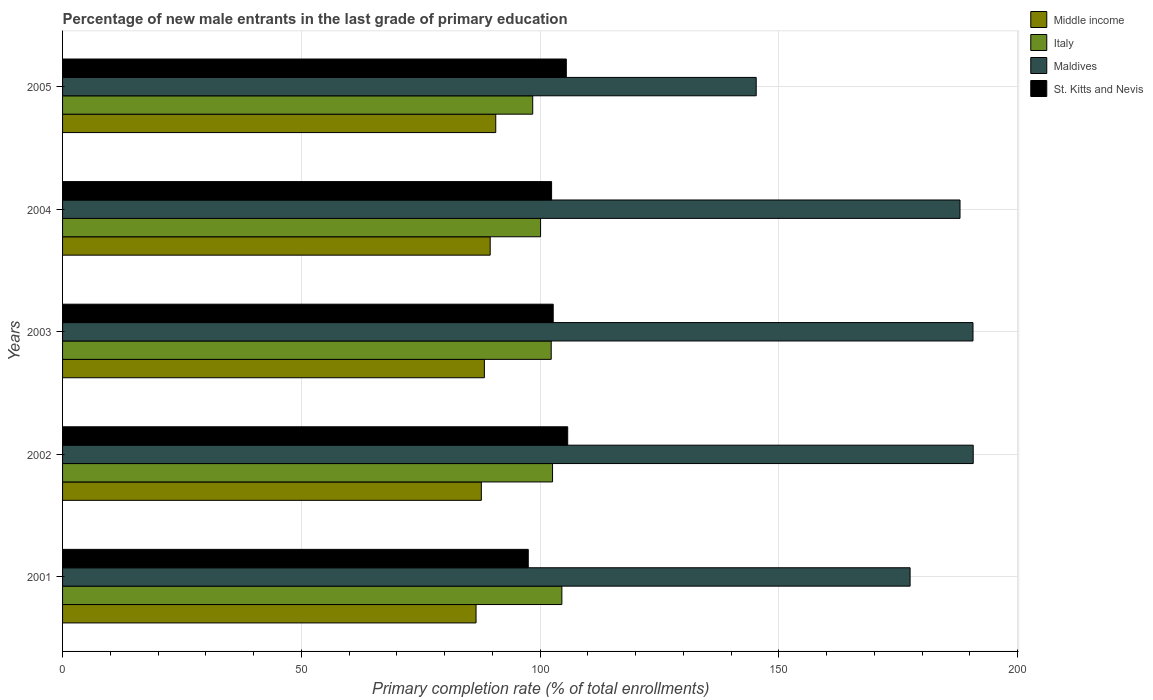How many different coloured bars are there?
Your answer should be very brief. 4. Are the number of bars per tick equal to the number of legend labels?
Make the answer very short. Yes. How many bars are there on the 1st tick from the top?
Provide a succinct answer. 4. What is the percentage of new male entrants in Italy in 2003?
Your response must be concise. 102.34. Across all years, what is the maximum percentage of new male entrants in Maldives?
Your response must be concise. 190.73. Across all years, what is the minimum percentage of new male entrants in Middle income?
Offer a very short reply. 86.6. In which year was the percentage of new male entrants in Italy maximum?
Your response must be concise. 2001. What is the total percentage of new male entrants in Maldives in the graph?
Offer a very short reply. 892.15. What is the difference between the percentage of new male entrants in Middle income in 2002 and that in 2005?
Keep it short and to the point. -3.02. What is the difference between the percentage of new male entrants in Maldives in 2004 and the percentage of new male entrants in Italy in 2002?
Provide a short and direct response. 85.34. What is the average percentage of new male entrants in Maldives per year?
Offer a terse response. 178.43. In the year 2004, what is the difference between the percentage of new male entrants in Middle income and percentage of new male entrants in Italy?
Make the answer very short. -10.55. What is the ratio of the percentage of new male entrants in Maldives in 2001 to that in 2002?
Keep it short and to the point. 0.93. Is the percentage of new male entrants in Maldives in 2001 less than that in 2005?
Your response must be concise. No. Is the difference between the percentage of new male entrants in Middle income in 2003 and 2004 greater than the difference between the percentage of new male entrants in Italy in 2003 and 2004?
Ensure brevity in your answer.  No. What is the difference between the highest and the second highest percentage of new male entrants in Middle income?
Make the answer very short. 1.17. What is the difference between the highest and the lowest percentage of new male entrants in Italy?
Give a very brief answer. 6.11. In how many years, is the percentage of new male entrants in Maldives greater than the average percentage of new male entrants in Maldives taken over all years?
Keep it short and to the point. 3. Is the sum of the percentage of new male entrants in Maldives in 2002 and 2003 greater than the maximum percentage of new male entrants in Italy across all years?
Make the answer very short. Yes. Is it the case that in every year, the sum of the percentage of new male entrants in St. Kitts and Nevis and percentage of new male entrants in Maldives is greater than the sum of percentage of new male entrants in Italy and percentage of new male entrants in Middle income?
Provide a succinct answer. Yes. What does the 2nd bar from the top in 2002 represents?
Provide a succinct answer. Maldives. What does the 2nd bar from the bottom in 2005 represents?
Give a very brief answer. Italy. How many bars are there?
Offer a terse response. 20. What is the difference between two consecutive major ticks on the X-axis?
Your response must be concise. 50. Does the graph contain any zero values?
Provide a short and direct response. No. Does the graph contain grids?
Your response must be concise. Yes. How many legend labels are there?
Ensure brevity in your answer.  4. What is the title of the graph?
Ensure brevity in your answer.  Percentage of new male entrants in the last grade of primary education. What is the label or title of the X-axis?
Provide a short and direct response. Primary completion rate (% of total enrollments). What is the label or title of the Y-axis?
Give a very brief answer. Years. What is the Primary completion rate (% of total enrollments) of Middle income in 2001?
Provide a short and direct response. 86.6. What is the Primary completion rate (% of total enrollments) in Italy in 2001?
Offer a very short reply. 104.57. What is the Primary completion rate (% of total enrollments) of Maldives in 2001?
Give a very brief answer. 177.51. What is the Primary completion rate (% of total enrollments) in St. Kitts and Nevis in 2001?
Your answer should be very brief. 97.54. What is the Primary completion rate (% of total enrollments) of Middle income in 2002?
Keep it short and to the point. 87.71. What is the Primary completion rate (% of total enrollments) in Italy in 2002?
Your response must be concise. 102.62. What is the Primary completion rate (% of total enrollments) of Maldives in 2002?
Ensure brevity in your answer.  190.73. What is the Primary completion rate (% of total enrollments) in St. Kitts and Nevis in 2002?
Keep it short and to the point. 105.8. What is the Primary completion rate (% of total enrollments) of Middle income in 2003?
Make the answer very short. 88.34. What is the Primary completion rate (% of total enrollments) of Italy in 2003?
Keep it short and to the point. 102.34. What is the Primary completion rate (% of total enrollments) in Maldives in 2003?
Offer a very short reply. 190.68. What is the Primary completion rate (% of total enrollments) of St. Kitts and Nevis in 2003?
Provide a succinct answer. 102.76. What is the Primary completion rate (% of total enrollments) of Middle income in 2004?
Make the answer very short. 89.56. What is the Primary completion rate (% of total enrollments) in Italy in 2004?
Keep it short and to the point. 100.11. What is the Primary completion rate (% of total enrollments) in Maldives in 2004?
Make the answer very short. 187.96. What is the Primary completion rate (% of total enrollments) of St. Kitts and Nevis in 2004?
Offer a very short reply. 102.42. What is the Primary completion rate (% of total enrollments) in Middle income in 2005?
Your response must be concise. 90.73. What is the Primary completion rate (% of total enrollments) in Italy in 2005?
Provide a succinct answer. 98.47. What is the Primary completion rate (% of total enrollments) in Maldives in 2005?
Give a very brief answer. 145.27. What is the Primary completion rate (% of total enrollments) in St. Kitts and Nevis in 2005?
Your response must be concise. 105.5. Across all years, what is the maximum Primary completion rate (% of total enrollments) of Middle income?
Provide a short and direct response. 90.73. Across all years, what is the maximum Primary completion rate (% of total enrollments) of Italy?
Your answer should be compact. 104.57. Across all years, what is the maximum Primary completion rate (% of total enrollments) of Maldives?
Give a very brief answer. 190.73. Across all years, what is the maximum Primary completion rate (% of total enrollments) in St. Kitts and Nevis?
Keep it short and to the point. 105.8. Across all years, what is the minimum Primary completion rate (% of total enrollments) in Middle income?
Offer a terse response. 86.6. Across all years, what is the minimum Primary completion rate (% of total enrollments) in Italy?
Your response must be concise. 98.47. Across all years, what is the minimum Primary completion rate (% of total enrollments) in Maldives?
Offer a very short reply. 145.27. Across all years, what is the minimum Primary completion rate (% of total enrollments) in St. Kitts and Nevis?
Keep it short and to the point. 97.54. What is the total Primary completion rate (% of total enrollments) of Middle income in the graph?
Give a very brief answer. 442.94. What is the total Primary completion rate (% of total enrollments) of Italy in the graph?
Offer a terse response. 508.12. What is the total Primary completion rate (% of total enrollments) in Maldives in the graph?
Offer a very short reply. 892.15. What is the total Primary completion rate (% of total enrollments) in St. Kitts and Nevis in the graph?
Your answer should be very brief. 514.02. What is the difference between the Primary completion rate (% of total enrollments) in Middle income in 2001 and that in 2002?
Your answer should be very brief. -1.11. What is the difference between the Primary completion rate (% of total enrollments) of Italy in 2001 and that in 2002?
Your answer should be very brief. 1.95. What is the difference between the Primary completion rate (% of total enrollments) in Maldives in 2001 and that in 2002?
Your answer should be very brief. -13.22. What is the difference between the Primary completion rate (% of total enrollments) in St. Kitts and Nevis in 2001 and that in 2002?
Your response must be concise. -8.26. What is the difference between the Primary completion rate (% of total enrollments) in Middle income in 2001 and that in 2003?
Keep it short and to the point. -1.74. What is the difference between the Primary completion rate (% of total enrollments) of Italy in 2001 and that in 2003?
Your answer should be very brief. 2.23. What is the difference between the Primary completion rate (% of total enrollments) in Maldives in 2001 and that in 2003?
Provide a succinct answer. -13.17. What is the difference between the Primary completion rate (% of total enrollments) in St. Kitts and Nevis in 2001 and that in 2003?
Your response must be concise. -5.22. What is the difference between the Primary completion rate (% of total enrollments) in Middle income in 2001 and that in 2004?
Offer a very short reply. -2.96. What is the difference between the Primary completion rate (% of total enrollments) of Italy in 2001 and that in 2004?
Ensure brevity in your answer.  4.46. What is the difference between the Primary completion rate (% of total enrollments) in Maldives in 2001 and that in 2004?
Your response must be concise. -10.46. What is the difference between the Primary completion rate (% of total enrollments) in St. Kitts and Nevis in 2001 and that in 2004?
Provide a succinct answer. -4.89. What is the difference between the Primary completion rate (% of total enrollments) in Middle income in 2001 and that in 2005?
Offer a very short reply. -4.13. What is the difference between the Primary completion rate (% of total enrollments) in Italy in 2001 and that in 2005?
Ensure brevity in your answer.  6.11. What is the difference between the Primary completion rate (% of total enrollments) in Maldives in 2001 and that in 2005?
Provide a short and direct response. 32.23. What is the difference between the Primary completion rate (% of total enrollments) in St. Kitts and Nevis in 2001 and that in 2005?
Provide a succinct answer. -7.97. What is the difference between the Primary completion rate (% of total enrollments) of Middle income in 2002 and that in 2003?
Offer a very short reply. -0.64. What is the difference between the Primary completion rate (% of total enrollments) in Italy in 2002 and that in 2003?
Offer a very short reply. 0.28. What is the difference between the Primary completion rate (% of total enrollments) of Maldives in 2002 and that in 2003?
Make the answer very short. 0.05. What is the difference between the Primary completion rate (% of total enrollments) of St. Kitts and Nevis in 2002 and that in 2003?
Ensure brevity in your answer.  3.04. What is the difference between the Primary completion rate (% of total enrollments) of Middle income in 2002 and that in 2004?
Provide a succinct answer. -1.85. What is the difference between the Primary completion rate (% of total enrollments) of Italy in 2002 and that in 2004?
Your response must be concise. 2.51. What is the difference between the Primary completion rate (% of total enrollments) in Maldives in 2002 and that in 2004?
Provide a short and direct response. 2.77. What is the difference between the Primary completion rate (% of total enrollments) of St. Kitts and Nevis in 2002 and that in 2004?
Ensure brevity in your answer.  3.37. What is the difference between the Primary completion rate (% of total enrollments) of Middle income in 2002 and that in 2005?
Offer a very short reply. -3.02. What is the difference between the Primary completion rate (% of total enrollments) of Italy in 2002 and that in 2005?
Keep it short and to the point. 4.15. What is the difference between the Primary completion rate (% of total enrollments) of Maldives in 2002 and that in 2005?
Keep it short and to the point. 45.45. What is the difference between the Primary completion rate (% of total enrollments) in St. Kitts and Nevis in 2002 and that in 2005?
Offer a terse response. 0.29. What is the difference between the Primary completion rate (% of total enrollments) of Middle income in 2003 and that in 2004?
Give a very brief answer. -1.22. What is the difference between the Primary completion rate (% of total enrollments) in Italy in 2003 and that in 2004?
Keep it short and to the point. 2.23. What is the difference between the Primary completion rate (% of total enrollments) of Maldives in 2003 and that in 2004?
Provide a short and direct response. 2.72. What is the difference between the Primary completion rate (% of total enrollments) of St. Kitts and Nevis in 2003 and that in 2004?
Keep it short and to the point. 0.34. What is the difference between the Primary completion rate (% of total enrollments) of Middle income in 2003 and that in 2005?
Your response must be concise. -2.38. What is the difference between the Primary completion rate (% of total enrollments) of Italy in 2003 and that in 2005?
Make the answer very short. 3.87. What is the difference between the Primary completion rate (% of total enrollments) of Maldives in 2003 and that in 2005?
Your answer should be very brief. 45.41. What is the difference between the Primary completion rate (% of total enrollments) of St. Kitts and Nevis in 2003 and that in 2005?
Ensure brevity in your answer.  -2.74. What is the difference between the Primary completion rate (% of total enrollments) of Middle income in 2004 and that in 2005?
Keep it short and to the point. -1.17. What is the difference between the Primary completion rate (% of total enrollments) in Italy in 2004 and that in 2005?
Your response must be concise. 1.64. What is the difference between the Primary completion rate (% of total enrollments) of Maldives in 2004 and that in 2005?
Provide a succinct answer. 42.69. What is the difference between the Primary completion rate (% of total enrollments) in St. Kitts and Nevis in 2004 and that in 2005?
Make the answer very short. -3.08. What is the difference between the Primary completion rate (% of total enrollments) in Middle income in 2001 and the Primary completion rate (% of total enrollments) in Italy in 2002?
Provide a short and direct response. -16.02. What is the difference between the Primary completion rate (% of total enrollments) of Middle income in 2001 and the Primary completion rate (% of total enrollments) of Maldives in 2002?
Your response must be concise. -104.13. What is the difference between the Primary completion rate (% of total enrollments) of Middle income in 2001 and the Primary completion rate (% of total enrollments) of St. Kitts and Nevis in 2002?
Offer a terse response. -19.2. What is the difference between the Primary completion rate (% of total enrollments) of Italy in 2001 and the Primary completion rate (% of total enrollments) of Maldives in 2002?
Offer a very short reply. -86.15. What is the difference between the Primary completion rate (% of total enrollments) in Italy in 2001 and the Primary completion rate (% of total enrollments) in St. Kitts and Nevis in 2002?
Your answer should be very brief. -1.22. What is the difference between the Primary completion rate (% of total enrollments) in Maldives in 2001 and the Primary completion rate (% of total enrollments) in St. Kitts and Nevis in 2002?
Provide a short and direct response. 71.71. What is the difference between the Primary completion rate (% of total enrollments) of Middle income in 2001 and the Primary completion rate (% of total enrollments) of Italy in 2003?
Give a very brief answer. -15.75. What is the difference between the Primary completion rate (% of total enrollments) of Middle income in 2001 and the Primary completion rate (% of total enrollments) of Maldives in 2003?
Offer a very short reply. -104.08. What is the difference between the Primary completion rate (% of total enrollments) of Middle income in 2001 and the Primary completion rate (% of total enrollments) of St. Kitts and Nevis in 2003?
Provide a succinct answer. -16.16. What is the difference between the Primary completion rate (% of total enrollments) in Italy in 2001 and the Primary completion rate (% of total enrollments) in Maldives in 2003?
Give a very brief answer. -86.11. What is the difference between the Primary completion rate (% of total enrollments) of Italy in 2001 and the Primary completion rate (% of total enrollments) of St. Kitts and Nevis in 2003?
Your response must be concise. 1.81. What is the difference between the Primary completion rate (% of total enrollments) of Maldives in 2001 and the Primary completion rate (% of total enrollments) of St. Kitts and Nevis in 2003?
Provide a succinct answer. 74.75. What is the difference between the Primary completion rate (% of total enrollments) in Middle income in 2001 and the Primary completion rate (% of total enrollments) in Italy in 2004?
Make the answer very short. -13.52. What is the difference between the Primary completion rate (% of total enrollments) of Middle income in 2001 and the Primary completion rate (% of total enrollments) of Maldives in 2004?
Your answer should be compact. -101.36. What is the difference between the Primary completion rate (% of total enrollments) of Middle income in 2001 and the Primary completion rate (% of total enrollments) of St. Kitts and Nevis in 2004?
Ensure brevity in your answer.  -15.83. What is the difference between the Primary completion rate (% of total enrollments) in Italy in 2001 and the Primary completion rate (% of total enrollments) in Maldives in 2004?
Offer a very short reply. -83.39. What is the difference between the Primary completion rate (% of total enrollments) in Italy in 2001 and the Primary completion rate (% of total enrollments) in St. Kitts and Nevis in 2004?
Your answer should be very brief. 2.15. What is the difference between the Primary completion rate (% of total enrollments) of Maldives in 2001 and the Primary completion rate (% of total enrollments) of St. Kitts and Nevis in 2004?
Your response must be concise. 75.08. What is the difference between the Primary completion rate (% of total enrollments) of Middle income in 2001 and the Primary completion rate (% of total enrollments) of Italy in 2005?
Offer a very short reply. -11.87. What is the difference between the Primary completion rate (% of total enrollments) in Middle income in 2001 and the Primary completion rate (% of total enrollments) in Maldives in 2005?
Ensure brevity in your answer.  -58.68. What is the difference between the Primary completion rate (% of total enrollments) in Middle income in 2001 and the Primary completion rate (% of total enrollments) in St. Kitts and Nevis in 2005?
Offer a terse response. -18.91. What is the difference between the Primary completion rate (% of total enrollments) of Italy in 2001 and the Primary completion rate (% of total enrollments) of Maldives in 2005?
Your response must be concise. -40.7. What is the difference between the Primary completion rate (% of total enrollments) of Italy in 2001 and the Primary completion rate (% of total enrollments) of St. Kitts and Nevis in 2005?
Ensure brevity in your answer.  -0.93. What is the difference between the Primary completion rate (% of total enrollments) of Maldives in 2001 and the Primary completion rate (% of total enrollments) of St. Kitts and Nevis in 2005?
Keep it short and to the point. 72. What is the difference between the Primary completion rate (% of total enrollments) of Middle income in 2002 and the Primary completion rate (% of total enrollments) of Italy in 2003?
Offer a terse response. -14.64. What is the difference between the Primary completion rate (% of total enrollments) in Middle income in 2002 and the Primary completion rate (% of total enrollments) in Maldives in 2003?
Your answer should be compact. -102.97. What is the difference between the Primary completion rate (% of total enrollments) in Middle income in 2002 and the Primary completion rate (% of total enrollments) in St. Kitts and Nevis in 2003?
Keep it short and to the point. -15.05. What is the difference between the Primary completion rate (% of total enrollments) in Italy in 2002 and the Primary completion rate (% of total enrollments) in Maldives in 2003?
Provide a succinct answer. -88.06. What is the difference between the Primary completion rate (% of total enrollments) of Italy in 2002 and the Primary completion rate (% of total enrollments) of St. Kitts and Nevis in 2003?
Offer a terse response. -0.14. What is the difference between the Primary completion rate (% of total enrollments) in Maldives in 2002 and the Primary completion rate (% of total enrollments) in St. Kitts and Nevis in 2003?
Offer a terse response. 87.97. What is the difference between the Primary completion rate (% of total enrollments) of Middle income in 2002 and the Primary completion rate (% of total enrollments) of Italy in 2004?
Provide a succinct answer. -12.41. What is the difference between the Primary completion rate (% of total enrollments) of Middle income in 2002 and the Primary completion rate (% of total enrollments) of Maldives in 2004?
Your response must be concise. -100.26. What is the difference between the Primary completion rate (% of total enrollments) of Middle income in 2002 and the Primary completion rate (% of total enrollments) of St. Kitts and Nevis in 2004?
Your answer should be compact. -14.72. What is the difference between the Primary completion rate (% of total enrollments) in Italy in 2002 and the Primary completion rate (% of total enrollments) in Maldives in 2004?
Offer a terse response. -85.34. What is the difference between the Primary completion rate (% of total enrollments) of Italy in 2002 and the Primary completion rate (% of total enrollments) of St. Kitts and Nevis in 2004?
Offer a terse response. 0.2. What is the difference between the Primary completion rate (% of total enrollments) in Maldives in 2002 and the Primary completion rate (% of total enrollments) in St. Kitts and Nevis in 2004?
Your answer should be compact. 88.3. What is the difference between the Primary completion rate (% of total enrollments) in Middle income in 2002 and the Primary completion rate (% of total enrollments) in Italy in 2005?
Provide a succinct answer. -10.76. What is the difference between the Primary completion rate (% of total enrollments) of Middle income in 2002 and the Primary completion rate (% of total enrollments) of Maldives in 2005?
Your response must be concise. -57.57. What is the difference between the Primary completion rate (% of total enrollments) in Middle income in 2002 and the Primary completion rate (% of total enrollments) in St. Kitts and Nevis in 2005?
Provide a short and direct response. -17.8. What is the difference between the Primary completion rate (% of total enrollments) in Italy in 2002 and the Primary completion rate (% of total enrollments) in Maldives in 2005?
Offer a very short reply. -42.65. What is the difference between the Primary completion rate (% of total enrollments) of Italy in 2002 and the Primary completion rate (% of total enrollments) of St. Kitts and Nevis in 2005?
Make the answer very short. -2.88. What is the difference between the Primary completion rate (% of total enrollments) of Maldives in 2002 and the Primary completion rate (% of total enrollments) of St. Kitts and Nevis in 2005?
Ensure brevity in your answer.  85.22. What is the difference between the Primary completion rate (% of total enrollments) in Middle income in 2003 and the Primary completion rate (% of total enrollments) in Italy in 2004?
Offer a terse response. -11.77. What is the difference between the Primary completion rate (% of total enrollments) of Middle income in 2003 and the Primary completion rate (% of total enrollments) of Maldives in 2004?
Offer a terse response. -99.62. What is the difference between the Primary completion rate (% of total enrollments) in Middle income in 2003 and the Primary completion rate (% of total enrollments) in St. Kitts and Nevis in 2004?
Your answer should be compact. -14.08. What is the difference between the Primary completion rate (% of total enrollments) in Italy in 2003 and the Primary completion rate (% of total enrollments) in Maldives in 2004?
Provide a short and direct response. -85.62. What is the difference between the Primary completion rate (% of total enrollments) in Italy in 2003 and the Primary completion rate (% of total enrollments) in St. Kitts and Nevis in 2004?
Your response must be concise. -0.08. What is the difference between the Primary completion rate (% of total enrollments) in Maldives in 2003 and the Primary completion rate (% of total enrollments) in St. Kitts and Nevis in 2004?
Provide a succinct answer. 88.26. What is the difference between the Primary completion rate (% of total enrollments) of Middle income in 2003 and the Primary completion rate (% of total enrollments) of Italy in 2005?
Ensure brevity in your answer.  -10.13. What is the difference between the Primary completion rate (% of total enrollments) of Middle income in 2003 and the Primary completion rate (% of total enrollments) of Maldives in 2005?
Give a very brief answer. -56.93. What is the difference between the Primary completion rate (% of total enrollments) of Middle income in 2003 and the Primary completion rate (% of total enrollments) of St. Kitts and Nevis in 2005?
Keep it short and to the point. -17.16. What is the difference between the Primary completion rate (% of total enrollments) in Italy in 2003 and the Primary completion rate (% of total enrollments) in Maldives in 2005?
Your answer should be very brief. -42.93. What is the difference between the Primary completion rate (% of total enrollments) of Italy in 2003 and the Primary completion rate (% of total enrollments) of St. Kitts and Nevis in 2005?
Provide a short and direct response. -3.16. What is the difference between the Primary completion rate (% of total enrollments) in Maldives in 2003 and the Primary completion rate (% of total enrollments) in St. Kitts and Nevis in 2005?
Give a very brief answer. 85.18. What is the difference between the Primary completion rate (% of total enrollments) of Middle income in 2004 and the Primary completion rate (% of total enrollments) of Italy in 2005?
Offer a very short reply. -8.91. What is the difference between the Primary completion rate (% of total enrollments) of Middle income in 2004 and the Primary completion rate (% of total enrollments) of Maldives in 2005?
Offer a very short reply. -55.71. What is the difference between the Primary completion rate (% of total enrollments) in Middle income in 2004 and the Primary completion rate (% of total enrollments) in St. Kitts and Nevis in 2005?
Your answer should be compact. -15.94. What is the difference between the Primary completion rate (% of total enrollments) of Italy in 2004 and the Primary completion rate (% of total enrollments) of Maldives in 2005?
Your answer should be compact. -45.16. What is the difference between the Primary completion rate (% of total enrollments) in Italy in 2004 and the Primary completion rate (% of total enrollments) in St. Kitts and Nevis in 2005?
Offer a terse response. -5.39. What is the difference between the Primary completion rate (% of total enrollments) in Maldives in 2004 and the Primary completion rate (% of total enrollments) in St. Kitts and Nevis in 2005?
Provide a short and direct response. 82.46. What is the average Primary completion rate (% of total enrollments) in Middle income per year?
Your response must be concise. 88.59. What is the average Primary completion rate (% of total enrollments) of Italy per year?
Offer a very short reply. 101.62. What is the average Primary completion rate (% of total enrollments) in Maldives per year?
Offer a very short reply. 178.43. What is the average Primary completion rate (% of total enrollments) in St. Kitts and Nevis per year?
Your answer should be compact. 102.8. In the year 2001, what is the difference between the Primary completion rate (% of total enrollments) of Middle income and Primary completion rate (% of total enrollments) of Italy?
Provide a succinct answer. -17.98. In the year 2001, what is the difference between the Primary completion rate (% of total enrollments) of Middle income and Primary completion rate (% of total enrollments) of Maldives?
Make the answer very short. -90.91. In the year 2001, what is the difference between the Primary completion rate (% of total enrollments) of Middle income and Primary completion rate (% of total enrollments) of St. Kitts and Nevis?
Make the answer very short. -10.94. In the year 2001, what is the difference between the Primary completion rate (% of total enrollments) in Italy and Primary completion rate (% of total enrollments) in Maldives?
Your answer should be compact. -72.93. In the year 2001, what is the difference between the Primary completion rate (% of total enrollments) of Italy and Primary completion rate (% of total enrollments) of St. Kitts and Nevis?
Provide a succinct answer. 7.04. In the year 2001, what is the difference between the Primary completion rate (% of total enrollments) of Maldives and Primary completion rate (% of total enrollments) of St. Kitts and Nevis?
Offer a terse response. 79.97. In the year 2002, what is the difference between the Primary completion rate (% of total enrollments) in Middle income and Primary completion rate (% of total enrollments) in Italy?
Your response must be concise. -14.91. In the year 2002, what is the difference between the Primary completion rate (% of total enrollments) of Middle income and Primary completion rate (% of total enrollments) of Maldives?
Ensure brevity in your answer.  -103.02. In the year 2002, what is the difference between the Primary completion rate (% of total enrollments) of Middle income and Primary completion rate (% of total enrollments) of St. Kitts and Nevis?
Provide a succinct answer. -18.09. In the year 2002, what is the difference between the Primary completion rate (% of total enrollments) in Italy and Primary completion rate (% of total enrollments) in Maldives?
Provide a succinct answer. -88.11. In the year 2002, what is the difference between the Primary completion rate (% of total enrollments) of Italy and Primary completion rate (% of total enrollments) of St. Kitts and Nevis?
Your answer should be compact. -3.18. In the year 2002, what is the difference between the Primary completion rate (% of total enrollments) in Maldives and Primary completion rate (% of total enrollments) in St. Kitts and Nevis?
Offer a terse response. 84.93. In the year 2003, what is the difference between the Primary completion rate (% of total enrollments) in Middle income and Primary completion rate (% of total enrollments) in Italy?
Your response must be concise. -14. In the year 2003, what is the difference between the Primary completion rate (% of total enrollments) of Middle income and Primary completion rate (% of total enrollments) of Maldives?
Provide a short and direct response. -102.34. In the year 2003, what is the difference between the Primary completion rate (% of total enrollments) of Middle income and Primary completion rate (% of total enrollments) of St. Kitts and Nevis?
Provide a short and direct response. -14.42. In the year 2003, what is the difference between the Primary completion rate (% of total enrollments) of Italy and Primary completion rate (% of total enrollments) of Maldives?
Give a very brief answer. -88.34. In the year 2003, what is the difference between the Primary completion rate (% of total enrollments) of Italy and Primary completion rate (% of total enrollments) of St. Kitts and Nevis?
Offer a terse response. -0.42. In the year 2003, what is the difference between the Primary completion rate (% of total enrollments) in Maldives and Primary completion rate (% of total enrollments) in St. Kitts and Nevis?
Your answer should be very brief. 87.92. In the year 2004, what is the difference between the Primary completion rate (% of total enrollments) of Middle income and Primary completion rate (% of total enrollments) of Italy?
Make the answer very short. -10.55. In the year 2004, what is the difference between the Primary completion rate (% of total enrollments) of Middle income and Primary completion rate (% of total enrollments) of Maldives?
Keep it short and to the point. -98.4. In the year 2004, what is the difference between the Primary completion rate (% of total enrollments) in Middle income and Primary completion rate (% of total enrollments) in St. Kitts and Nevis?
Offer a very short reply. -12.86. In the year 2004, what is the difference between the Primary completion rate (% of total enrollments) in Italy and Primary completion rate (% of total enrollments) in Maldives?
Your response must be concise. -87.85. In the year 2004, what is the difference between the Primary completion rate (% of total enrollments) of Italy and Primary completion rate (% of total enrollments) of St. Kitts and Nevis?
Keep it short and to the point. -2.31. In the year 2004, what is the difference between the Primary completion rate (% of total enrollments) in Maldives and Primary completion rate (% of total enrollments) in St. Kitts and Nevis?
Your answer should be very brief. 85.54. In the year 2005, what is the difference between the Primary completion rate (% of total enrollments) of Middle income and Primary completion rate (% of total enrollments) of Italy?
Offer a terse response. -7.74. In the year 2005, what is the difference between the Primary completion rate (% of total enrollments) of Middle income and Primary completion rate (% of total enrollments) of Maldives?
Your response must be concise. -54.55. In the year 2005, what is the difference between the Primary completion rate (% of total enrollments) of Middle income and Primary completion rate (% of total enrollments) of St. Kitts and Nevis?
Keep it short and to the point. -14.78. In the year 2005, what is the difference between the Primary completion rate (% of total enrollments) of Italy and Primary completion rate (% of total enrollments) of Maldives?
Provide a succinct answer. -46.81. In the year 2005, what is the difference between the Primary completion rate (% of total enrollments) in Italy and Primary completion rate (% of total enrollments) in St. Kitts and Nevis?
Ensure brevity in your answer.  -7.04. In the year 2005, what is the difference between the Primary completion rate (% of total enrollments) in Maldives and Primary completion rate (% of total enrollments) in St. Kitts and Nevis?
Your answer should be very brief. 39.77. What is the ratio of the Primary completion rate (% of total enrollments) of Middle income in 2001 to that in 2002?
Make the answer very short. 0.99. What is the ratio of the Primary completion rate (% of total enrollments) in Italy in 2001 to that in 2002?
Ensure brevity in your answer.  1.02. What is the ratio of the Primary completion rate (% of total enrollments) in Maldives in 2001 to that in 2002?
Offer a very short reply. 0.93. What is the ratio of the Primary completion rate (% of total enrollments) of St. Kitts and Nevis in 2001 to that in 2002?
Your answer should be compact. 0.92. What is the ratio of the Primary completion rate (% of total enrollments) in Middle income in 2001 to that in 2003?
Your response must be concise. 0.98. What is the ratio of the Primary completion rate (% of total enrollments) of Italy in 2001 to that in 2003?
Ensure brevity in your answer.  1.02. What is the ratio of the Primary completion rate (% of total enrollments) of Maldives in 2001 to that in 2003?
Offer a terse response. 0.93. What is the ratio of the Primary completion rate (% of total enrollments) of St. Kitts and Nevis in 2001 to that in 2003?
Keep it short and to the point. 0.95. What is the ratio of the Primary completion rate (% of total enrollments) in Middle income in 2001 to that in 2004?
Offer a very short reply. 0.97. What is the ratio of the Primary completion rate (% of total enrollments) in Italy in 2001 to that in 2004?
Provide a succinct answer. 1.04. What is the ratio of the Primary completion rate (% of total enrollments) in St. Kitts and Nevis in 2001 to that in 2004?
Your answer should be compact. 0.95. What is the ratio of the Primary completion rate (% of total enrollments) of Middle income in 2001 to that in 2005?
Offer a terse response. 0.95. What is the ratio of the Primary completion rate (% of total enrollments) of Italy in 2001 to that in 2005?
Your response must be concise. 1.06. What is the ratio of the Primary completion rate (% of total enrollments) of Maldives in 2001 to that in 2005?
Your answer should be very brief. 1.22. What is the ratio of the Primary completion rate (% of total enrollments) in St. Kitts and Nevis in 2001 to that in 2005?
Your response must be concise. 0.92. What is the ratio of the Primary completion rate (% of total enrollments) of Middle income in 2002 to that in 2003?
Offer a terse response. 0.99. What is the ratio of the Primary completion rate (% of total enrollments) of Italy in 2002 to that in 2003?
Offer a very short reply. 1. What is the ratio of the Primary completion rate (% of total enrollments) of St. Kitts and Nevis in 2002 to that in 2003?
Ensure brevity in your answer.  1.03. What is the ratio of the Primary completion rate (% of total enrollments) in Middle income in 2002 to that in 2004?
Provide a succinct answer. 0.98. What is the ratio of the Primary completion rate (% of total enrollments) of Italy in 2002 to that in 2004?
Your response must be concise. 1.02. What is the ratio of the Primary completion rate (% of total enrollments) of Maldives in 2002 to that in 2004?
Make the answer very short. 1.01. What is the ratio of the Primary completion rate (% of total enrollments) in St. Kitts and Nevis in 2002 to that in 2004?
Offer a very short reply. 1.03. What is the ratio of the Primary completion rate (% of total enrollments) of Middle income in 2002 to that in 2005?
Provide a succinct answer. 0.97. What is the ratio of the Primary completion rate (% of total enrollments) of Italy in 2002 to that in 2005?
Your answer should be compact. 1.04. What is the ratio of the Primary completion rate (% of total enrollments) of Maldives in 2002 to that in 2005?
Keep it short and to the point. 1.31. What is the ratio of the Primary completion rate (% of total enrollments) in Middle income in 2003 to that in 2004?
Your response must be concise. 0.99. What is the ratio of the Primary completion rate (% of total enrollments) in Italy in 2003 to that in 2004?
Keep it short and to the point. 1.02. What is the ratio of the Primary completion rate (% of total enrollments) in Maldives in 2003 to that in 2004?
Your answer should be very brief. 1.01. What is the ratio of the Primary completion rate (% of total enrollments) in St. Kitts and Nevis in 2003 to that in 2004?
Provide a short and direct response. 1. What is the ratio of the Primary completion rate (% of total enrollments) of Middle income in 2003 to that in 2005?
Your answer should be very brief. 0.97. What is the ratio of the Primary completion rate (% of total enrollments) of Italy in 2003 to that in 2005?
Ensure brevity in your answer.  1.04. What is the ratio of the Primary completion rate (% of total enrollments) of Maldives in 2003 to that in 2005?
Provide a short and direct response. 1.31. What is the ratio of the Primary completion rate (% of total enrollments) in Middle income in 2004 to that in 2005?
Offer a terse response. 0.99. What is the ratio of the Primary completion rate (% of total enrollments) of Italy in 2004 to that in 2005?
Offer a very short reply. 1.02. What is the ratio of the Primary completion rate (% of total enrollments) in Maldives in 2004 to that in 2005?
Give a very brief answer. 1.29. What is the ratio of the Primary completion rate (% of total enrollments) in St. Kitts and Nevis in 2004 to that in 2005?
Your answer should be compact. 0.97. What is the difference between the highest and the second highest Primary completion rate (% of total enrollments) in Middle income?
Your answer should be very brief. 1.17. What is the difference between the highest and the second highest Primary completion rate (% of total enrollments) of Italy?
Offer a terse response. 1.95. What is the difference between the highest and the second highest Primary completion rate (% of total enrollments) of Maldives?
Your answer should be compact. 0.05. What is the difference between the highest and the second highest Primary completion rate (% of total enrollments) of St. Kitts and Nevis?
Provide a succinct answer. 0.29. What is the difference between the highest and the lowest Primary completion rate (% of total enrollments) in Middle income?
Offer a terse response. 4.13. What is the difference between the highest and the lowest Primary completion rate (% of total enrollments) of Italy?
Your answer should be compact. 6.11. What is the difference between the highest and the lowest Primary completion rate (% of total enrollments) of Maldives?
Your answer should be compact. 45.45. What is the difference between the highest and the lowest Primary completion rate (% of total enrollments) in St. Kitts and Nevis?
Give a very brief answer. 8.26. 